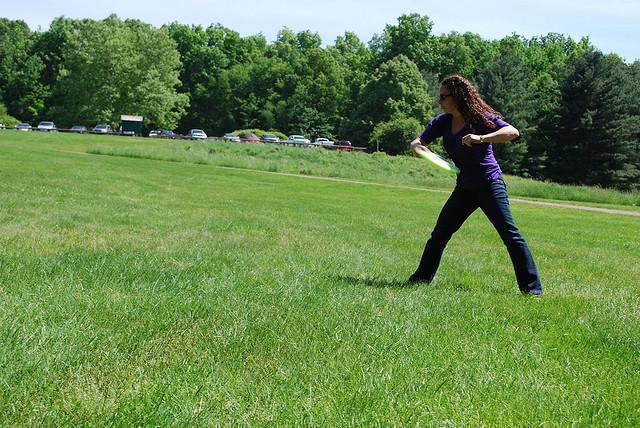What color are her glasses?
Indicate the correct response and explain using: 'Answer: answer
Rationale: rationale.'
Options: Gold, red, white, black. Answer: black.
Rationale: The glasses are too dark to be white, but lack any other color. 